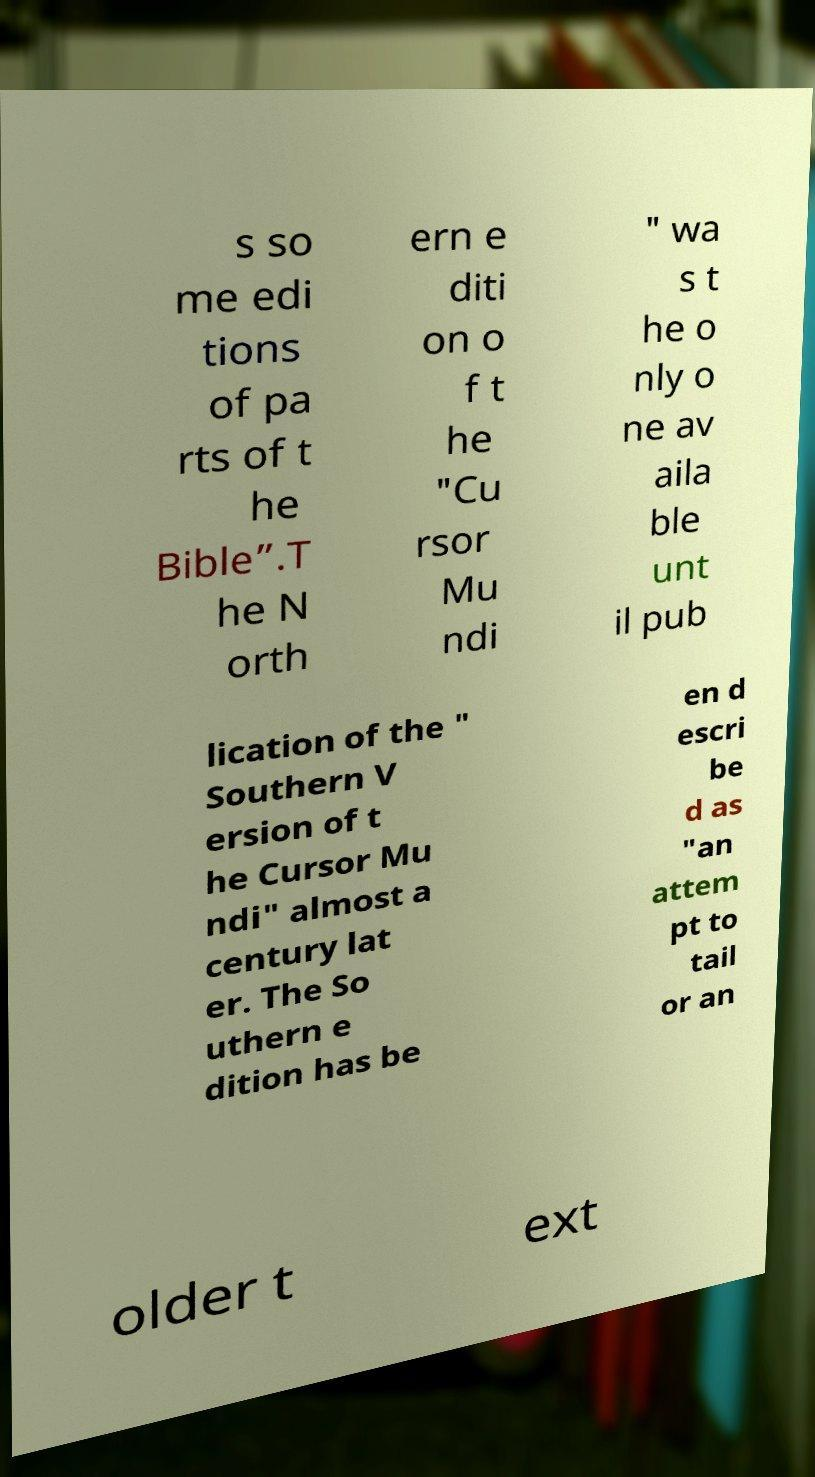Can you accurately transcribe the text from the provided image for me? s so me edi tions of pa rts of t he Bible”.T he N orth ern e diti on o f t he "Cu rsor Mu ndi " wa s t he o nly o ne av aila ble unt il pub lication of the " Southern V ersion of t he Cursor Mu ndi" almost a century lat er. The So uthern e dition has be en d escri be d as "an attem pt to tail or an older t ext 